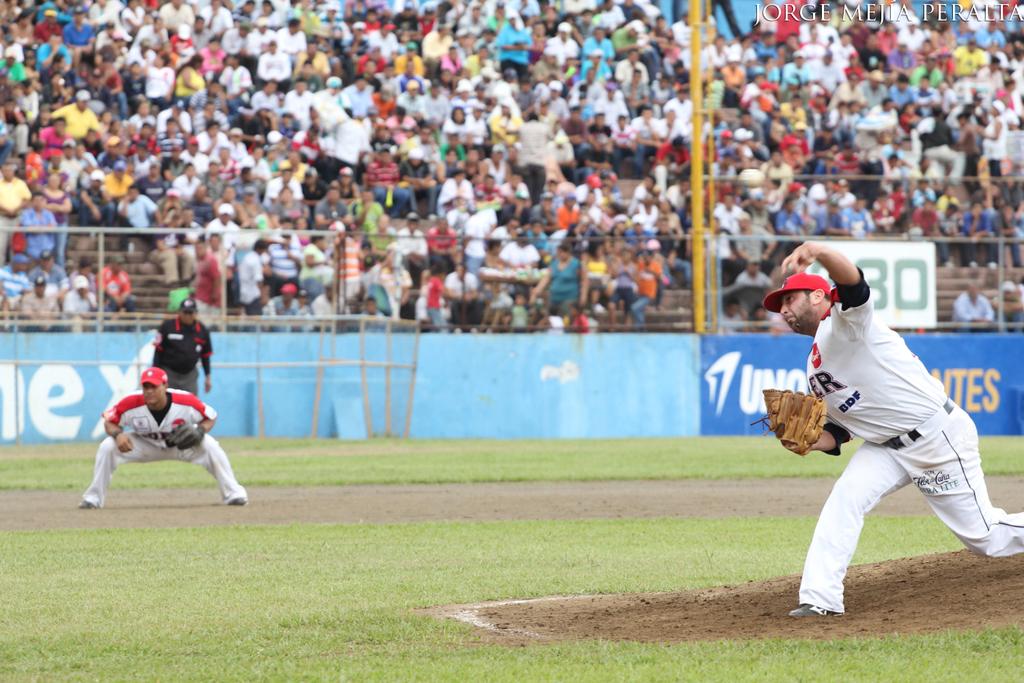What is the last digit in teal on the white sign?
Make the answer very short. 0. How many players are on the field?
Your answer should be very brief. Answering does not require reading text in the image. 